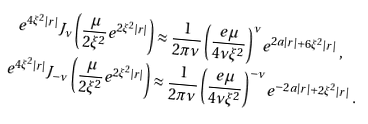<formula> <loc_0><loc_0><loc_500><loc_500>e ^ { 4 \xi ^ { 2 } | r | } J _ { \nu } \left ( \frac { \mu } { 2 \xi ^ { 2 } } e ^ { 2 \xi ^ { 2 } | r | } \right ) & \approx \frac { 1 } { 2 \pi \nu } \left ( \frac { e \, \mu } { 4 \nu \xi ^ { 2 } } \right ) ^ { \nu } e ^ { 2 a | r | + 6 \xi ^ { 2 } | r | } \ , \\ e ^ { 4 \xi ^ { 2 } | r | } J _ { - \nu } \left ( \frac { \mu } { 2 \xi ^ { 2 } } e ^ { 2 \xi ^ { 2 } | r | } \right ) & \approx \frac { 1 } { 2 \pi \nu } \left ( \frac { e \, \mu } { 4 \nu \xi ^ { 2 } } \right ) ^ { - \nu } e ^ { - 2 a | r | + 2 \xi ^ { 2 } | r | } \ .</formula> 